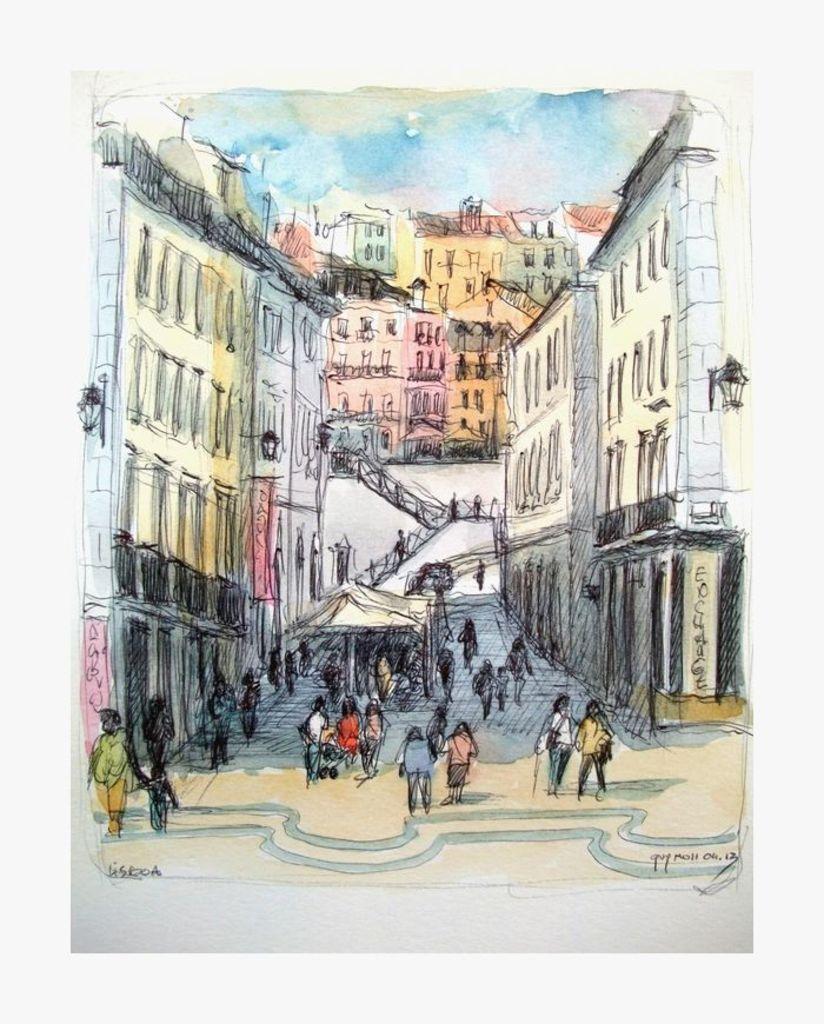Could you give a brief overview of what you see in this image? In this image, we can see depiction of persons and buildings. 